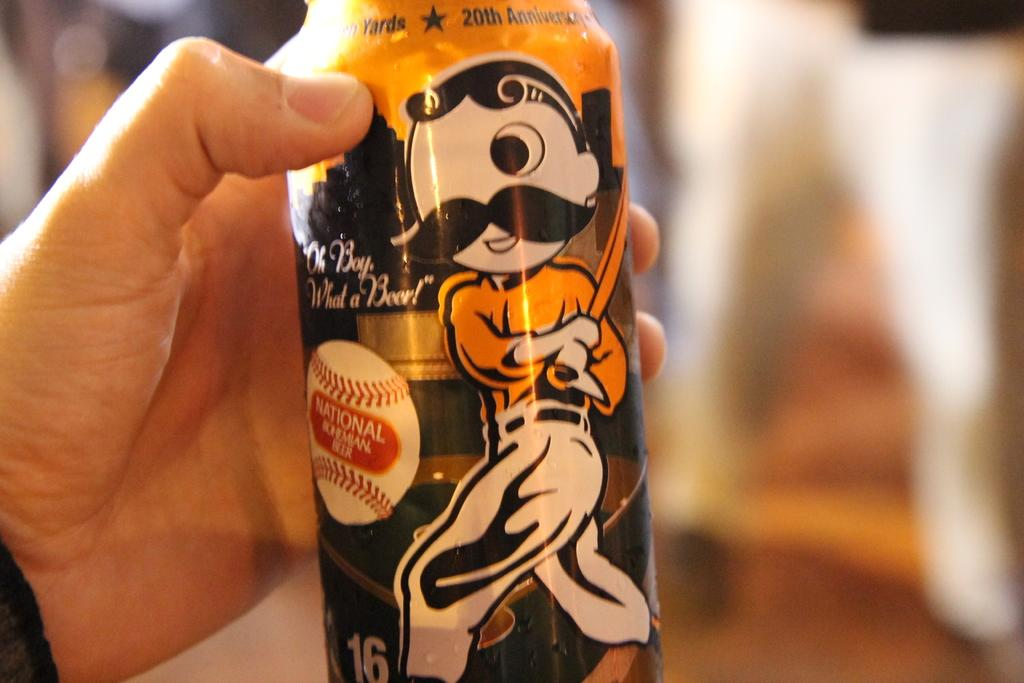<image>
Offer a succinct explanation of the picture presented. A person is holding a beer can with a cartoon baseball player hitting a baseball that says National Bohemian Beer. 